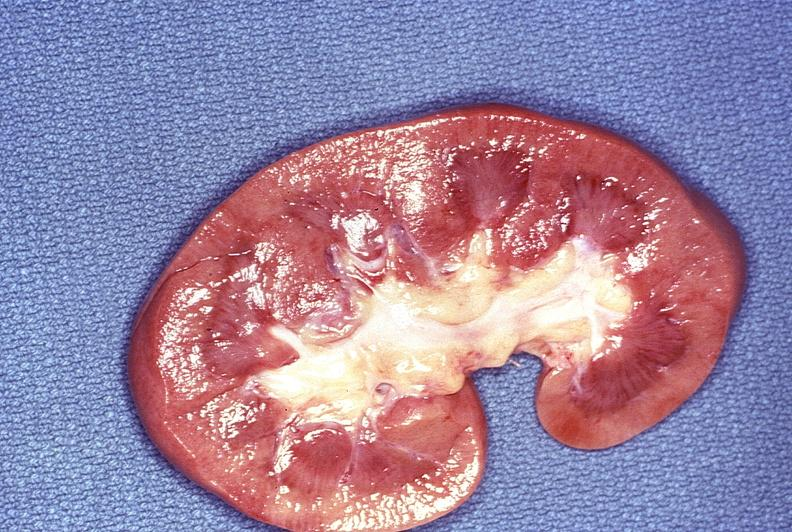where is this?
Answer the question using a single word or phrase. Urinary 